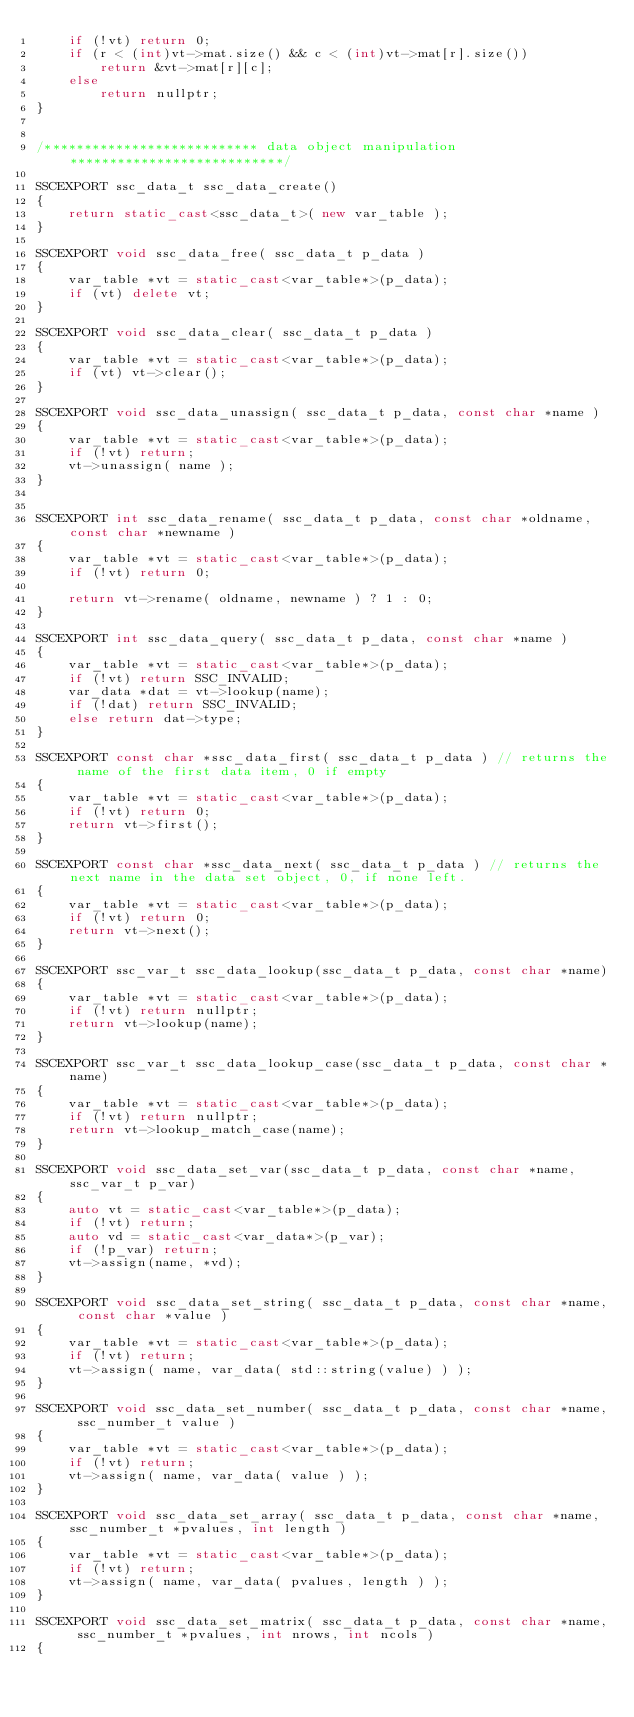Convert code to text. <code><loc_0><loc_0><loc_500><loc_500><_C++_>    if (!vt) return 0;
    if (r < (int)vt->mat.size() && c < (int)vt->mat[r].size())
        return &vt->mat[r][c];
    else
        return nullptr;
}


/*************************** data object manipulation ***************************/

SSCEXPORT ssc_data_t ssc_data_create()
{
	return static_cast<ssc_data_t>( new var_table );
}

SSCEXPORT void ssc_data_free( ssc_data_t p_data )
{
	var_table *vt = static_cast<var_table*>(p_data);
	if (vt) delete vt;
}

SSCEXPORT void ssc_data_clear( ssc_data_t p_data )
{
	var_table *vt = static_cast<var_table*>(p_data);
	if (vt) vt->clear();
}

SSCEXPORT void ssc_data_unassign( ssc_data_t p_data, const char *name )
{
	var_table *vt = static_cast<var_table*>(p_data);
	if (!vt) return;
	vt->unassign( name );
}


SSCEXPORT int ssc_data_rename( ssc_data_t p_data, const char *oldname, const char *newname )
{
	var_table *vt = static_cast<var_table*>(p_data);
	if (!vt) return 0;

	return vt->rename( oldname, newname ) ? 1 : 0;
}

SSCEXPORT int ssc_data_query( ssc_data_t p_data, const char *name )
{
	var_table *vt = static_cast<var_table*>(p_data);
	if (!vt) return SSC_INVALID;
	var_data *dat = vt->lookup(name);
	if (!dat) return SSC_INVALID;
	else return dat->type;
}

SSCEXPORT const char *ssc_data_first( ssc_data_t p_data ) // returns the name of the first data item, 0 if empty
{
	var_table *vt = static_cast<var_table*>(p_data);
	if (!vt) return 0;
	return vt->first();
}

SSCEXPORT const char *ssc_data_next( ssc_data_t p_data ) // returns the next name in the data set object, 0, if none left.
{
	var_table *vt = static_cast<var_table*>(p_data);
	if (!vt) return 0;
	return vt->next();
}

SSCEXPORT ssc_var_t ssc_data_lookup(ssc_data_t p_data, const char *name)
{
    var_table *vt = static_cast<var_table*>(p_data);
    if (!vt) return nullptr;
    return vt->lookup(name);
}

SSCEXPORT ssc_var_t ssc_data_lookup_case(ssc_data_t p_data, const char *name)
{
    var_table *vt = static_cast<var_table*>(p_data);
    if (!vt) return nullptr;
    return vt->lookup_match_case(name);
}

SSCEXPORT void ssc_data_set_var(ssc_data_t p_data, const char *name, ssc_var_t p_var)
{
    auto vt = static_cast<var_table*>(p_data);
    if (!vt) return;
    auto vd = static_cast<var_data*>(p_var);
    if (!p_var) return;
    vt->assign(name, *vd);
}

SSCEXPORT void ssc_data_set_string( ssc_data_t p_data, const char *name, const char *value )
{
	var_table *vt = static_cast<var_table*>(p_data);
	if (!vt) return;
	vt->assign( name, var_data( std::string(value) ) );
}

SSCEXPORT void ssc_data_set_number( ssc_data_t p_data, const char *name, ssc_number_t value )
{
	var_table *vt = static_cast<var_table*>(p_data);
	if (!vt) return;
	vt->assign( name, var_data( value ) );
}

SSCEXPORT void ssc_data_set_array( ssc_data_t p_data, const char *name, ssc_number_t *pvalues, int length )
{
	var_table *vt = static_cast<var_table*>(p_data);
	if (!vt) return;
	vt->assign( name, var_data( pvalues, length ) );
}

SSCEXPORT void ssc_data_set_matrix( ssc_data_t p_data, const char *name, ssc_number_t *pvalues, int nrows, int ncols )
{</code> 